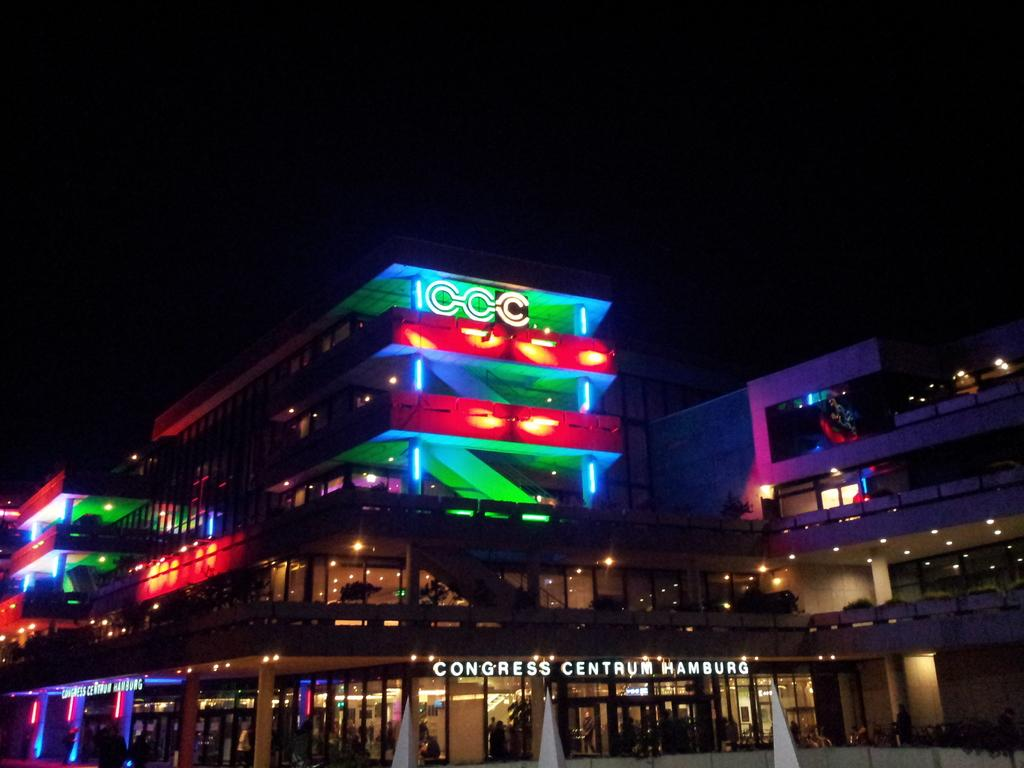What type of structure is visible in the image? There is a building in the image. How are the lights on the building described? The building has different color lights on it. What text is written on the building? The text "Congress Centrum Hamburg" is written on the building. Where is the faucet located in the image? There is no faucet present in the image. What time of day is it in the image based on the position of the sun? The position of the sun cannot be determined from the image, as it does not show the sky or any celestial bodies. 